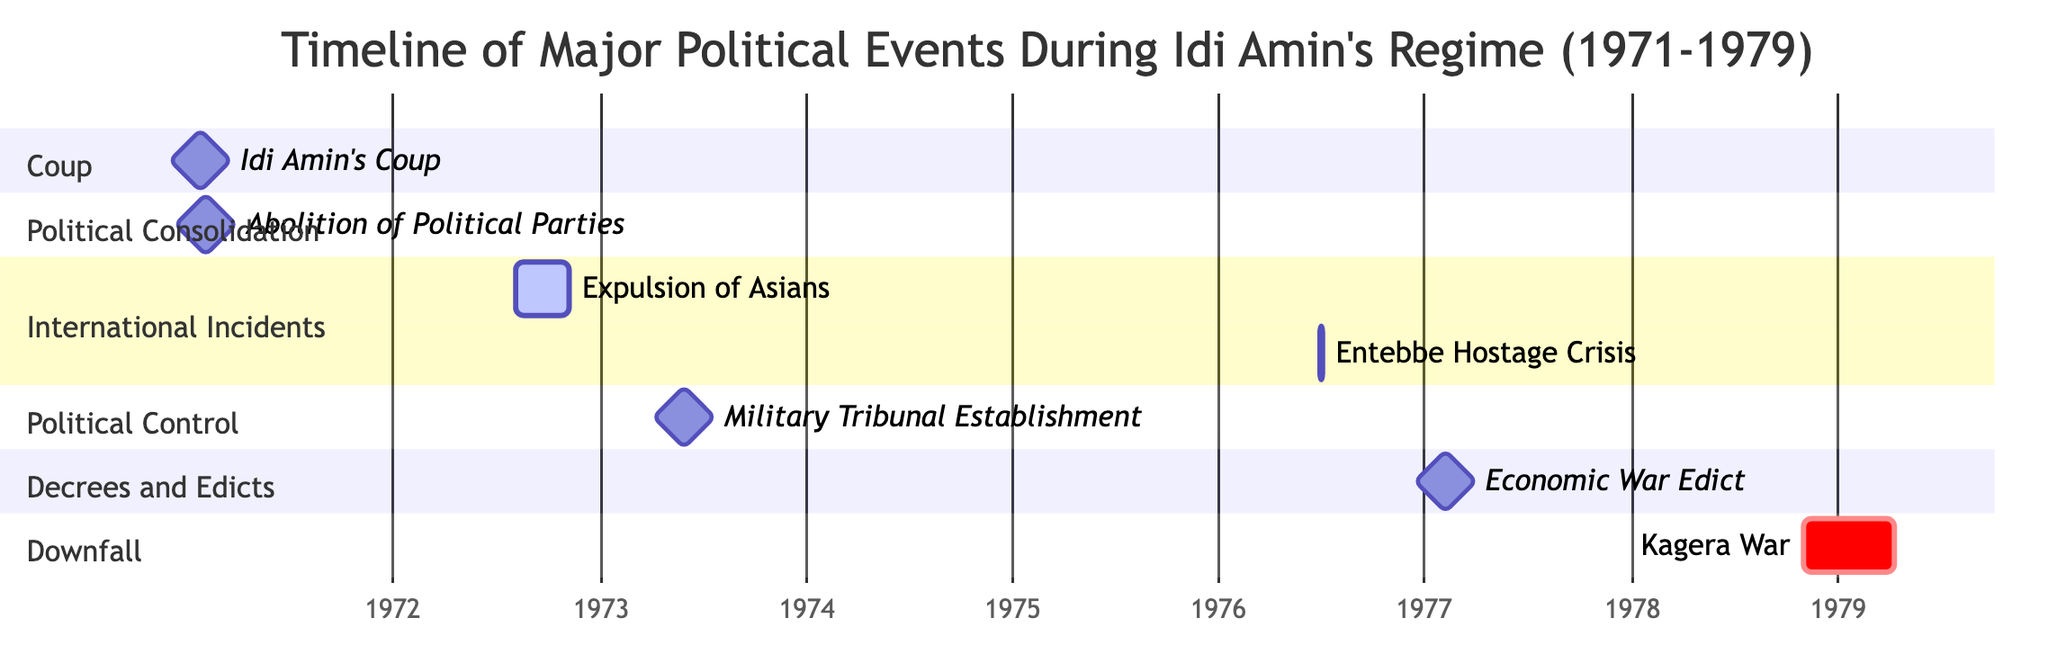What event marked the beginning of Idi Amin's regime? The diagram indicates that Idi Amin's regime began with his coup on January 25, 1971. This single milestone event is marked at the start of the timeline.
Answer: Idi Amin's Coup How many nodes represent significant international incidents? The Gantt chart has two events classified under the section of International Incidents: the Expulsion of Asians and the Entebbe Hostage Crisis, making a total of two such nodes.
Answer: 2 What was one primary action taken during the Political Consolidation phase? According to the diagram, in the section titled Political Consolidation, the event listed is the Abolition of Political Parties, which occurred on February 2, 1971.
Answer: Abolition of Political Parties During which event did Idi Amin declare an 'Economic War'? The diagram specifies that the Economic War Edict was declared on February 5, 1977, which is part of the Decrees and Edicts section.
Answer: Economic War Edict What is the duration of the Kagera War as depicted in the Gantt chart? The Kagera War is shown to begin on October 30, 1978, and ends on April 11, 1979. To find the duration, one computes the time span between these two dates. The timeline visually depicts this event lasting approximately 6 months and 11 days.
Answer: 6 months What significant international incident occurred during the year 1976? The Entebbe Hostage Crisis, listed in the International Incidents section, began on June 27, 1976, and ended on July 4, 1976, highlighting this event as significant within that year.
Answer: Entebbe Hostage Crisis What phase is the establishment of military tribunals associated with? In the Gantt chart, the event Military Tribunal Establishment is categorized under the Political Control phase, indicating its purpose of controlling opposition during Amin's regime.
Answer: Political Control These milestones represent the end of Amin's regime. The diagram concludes with the Kagera War, marking Amin's downfall, visualized as a critical event in the timeline under the Downfall section.
Answer: Kagera War 